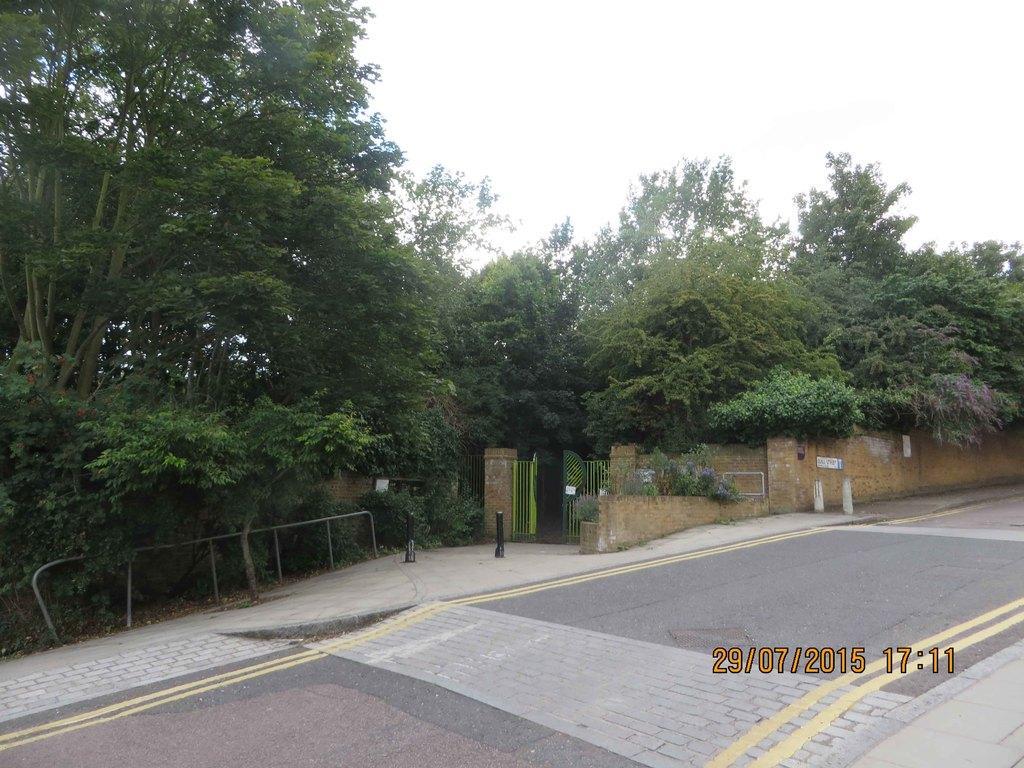Could you give a brief overview of what you see in this image? In this picture, we can see the road, path, poles, trees, plants, poles, gate, wall, and the sky, we can see time and date on the bottom right side of the picture. 